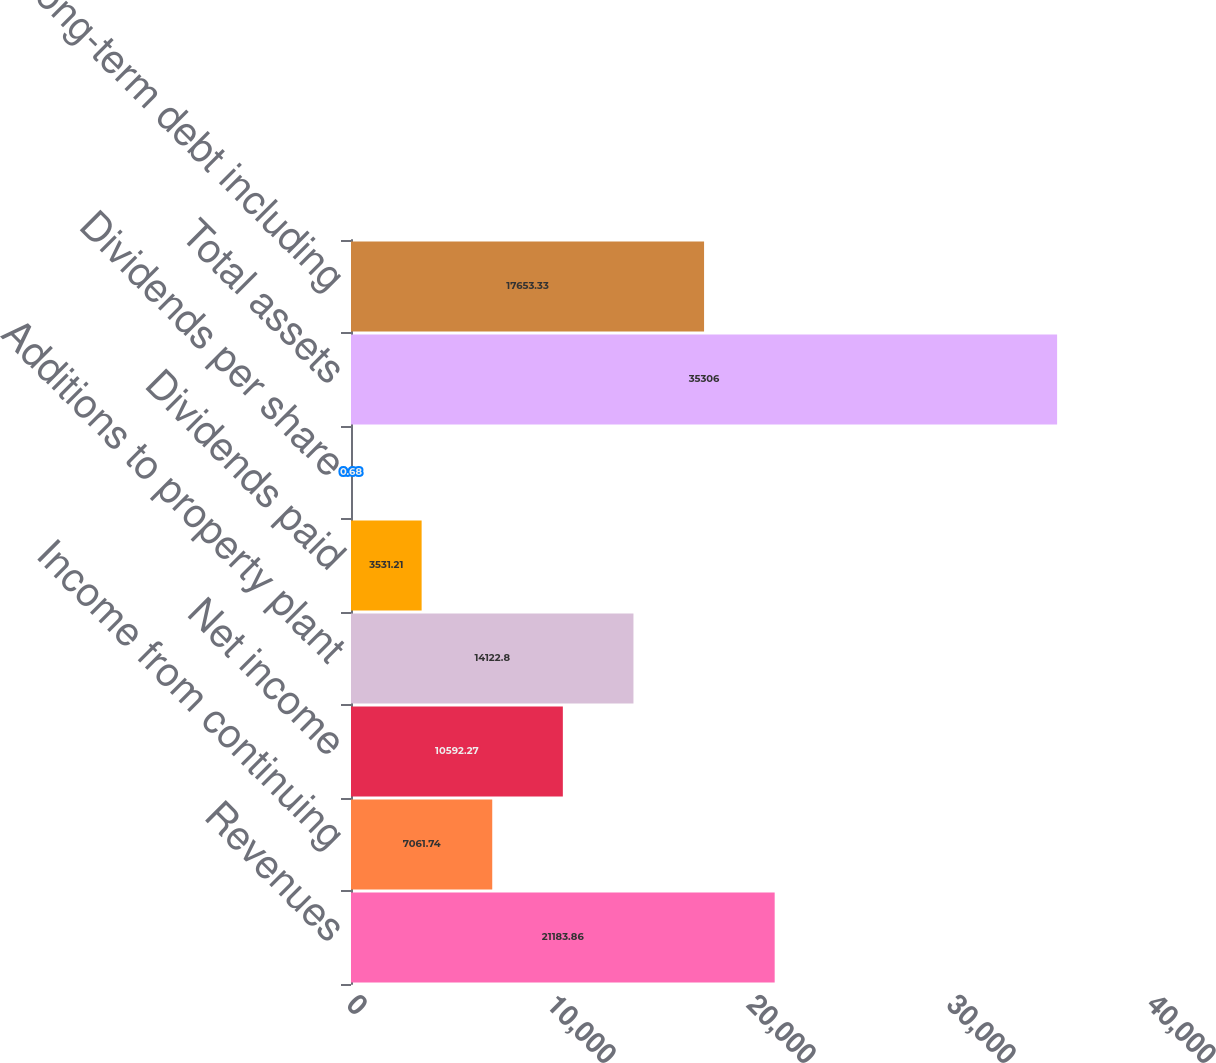Convert chart. <chart><loc_0><loc_0><loc_500><loc_500><bar_chart><fcel>Revenues<fcel>Income from continuing<fcel>Net income<fcel>Additions to property plant<fcel>Dividends paid<fcel>Dividends per share<fcel>Total assets<fcel>Total long-term debt including<nl><fcel>21183.9<fcel>7061.74<fcel>10592.3<fcel>14122.8<fcel>3531.21<fcel>0.68<fcel>35306<fcel>17653.3<nl></chart> 